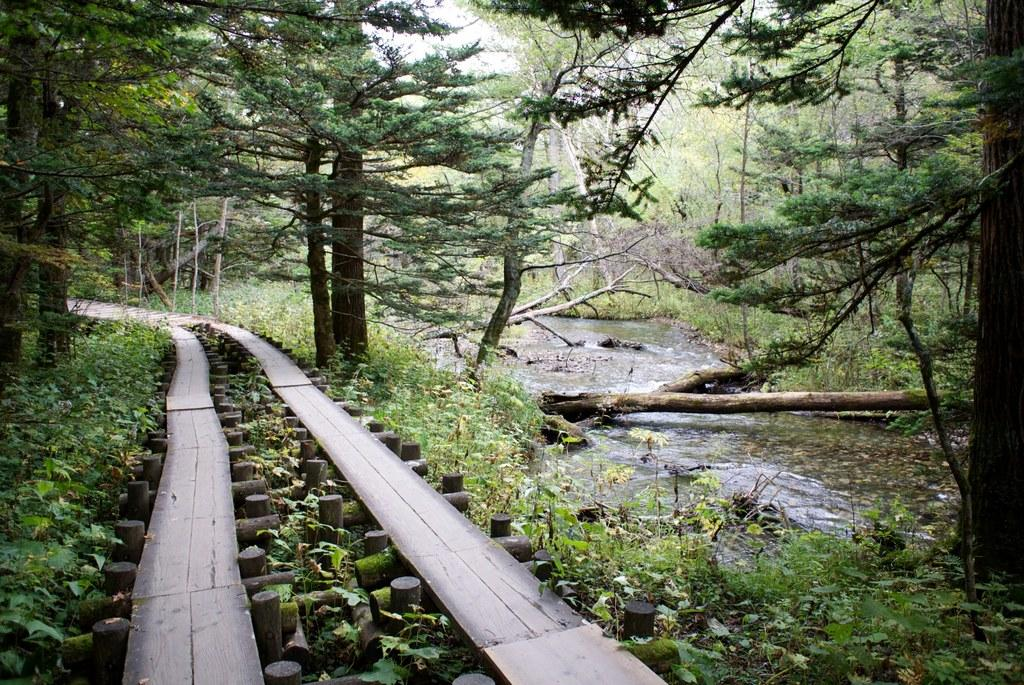What type of vegetation can be seen in the image? There are trees in the image. What is the color of the trees? The trees are green. What else is visible in the image besides the trees? There is water and wooden sticks visible in the image. What is the color of the sky in the image? The sky is white in color. Can you see any knots in the wooden sticks in the image? There is no mention of knots in the provided facts, and therefore we cannot determine if there are any knots in the wooden sticks in the image. 